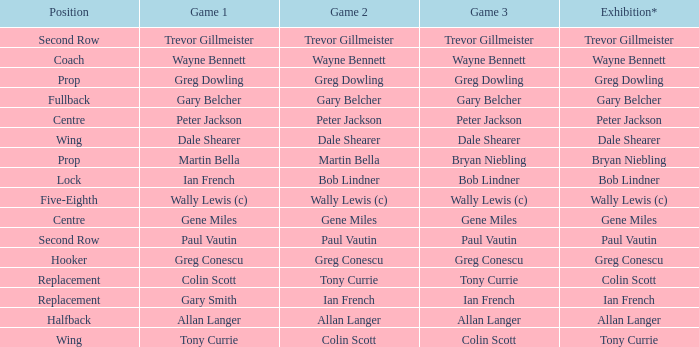What exhibition has greg conescu as game 1? Greg Conescu. 